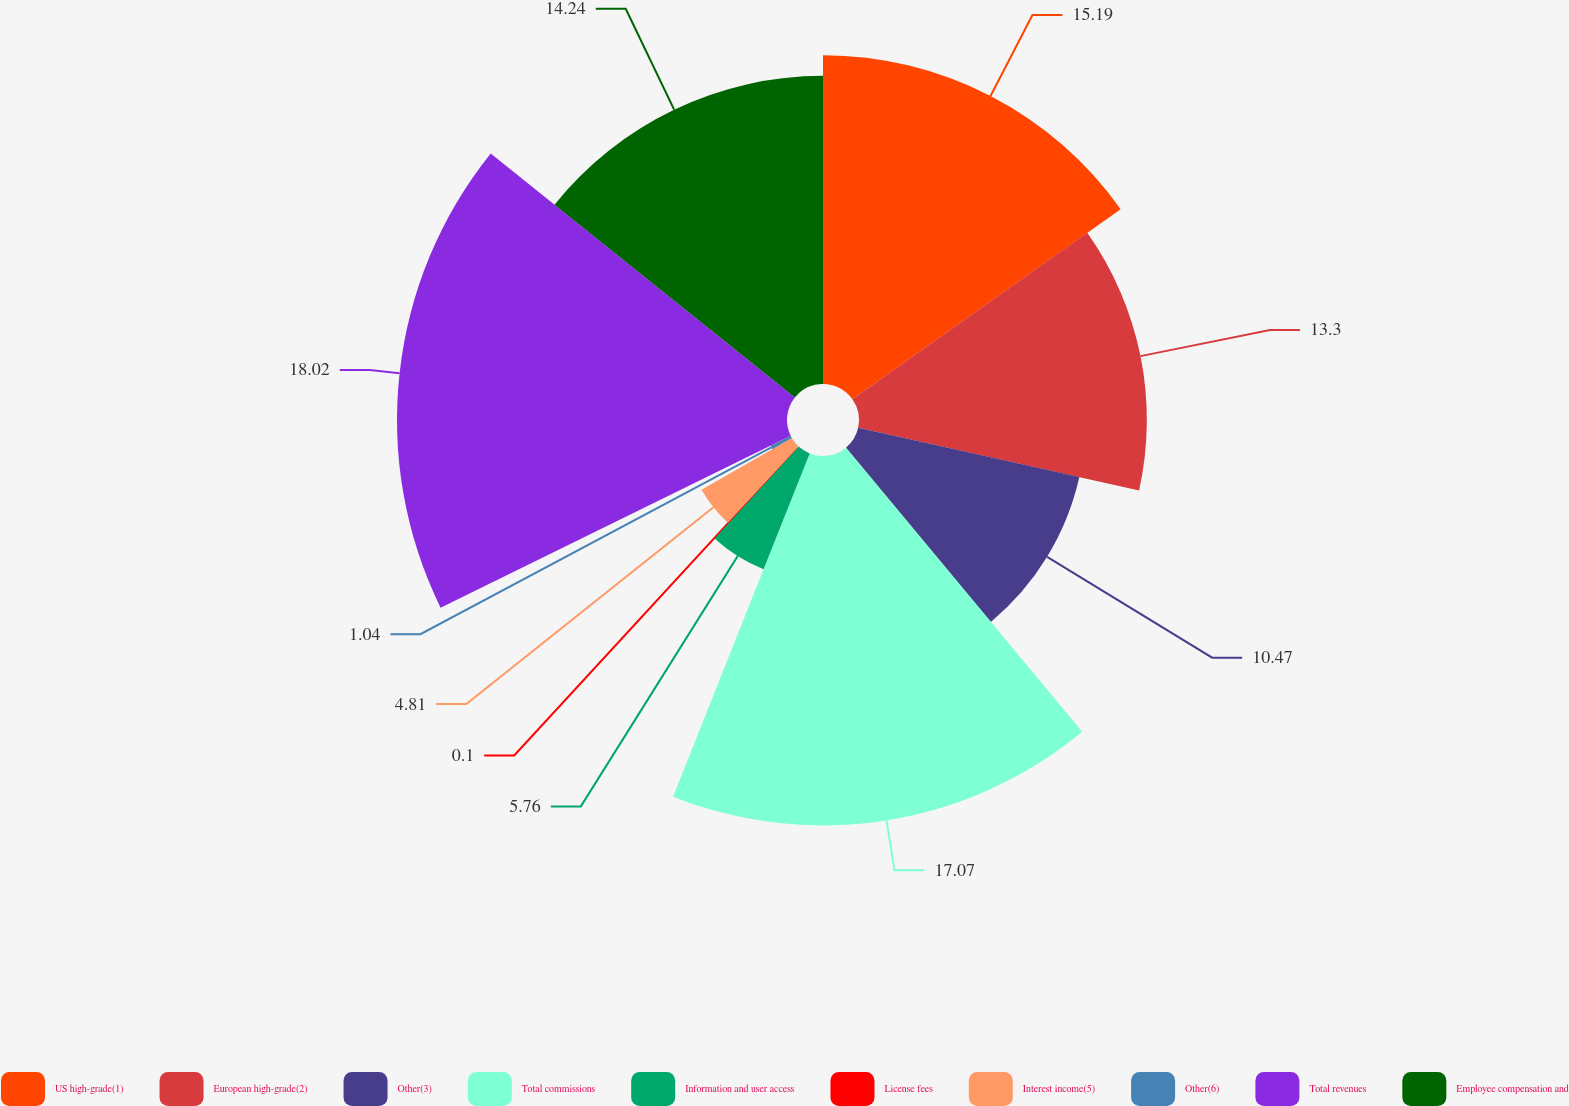Convert chart to OTSL. <chart><loc_0><loc_0><loc_500><loc_500><pie_chart><fcel>US high-grade(1)<fcel>European high-grade(2)<fcel>Other(3)<fcel>Total commissions<fcel>Information and user access<fcel>License fees<fcel>Interest income(5)<fcel>Other(6)<fcel>Total revenues<fcel>Employee compensation and<nl><fcel>15.19%<fcel>13.3%<fcel>10.47%<fcel>17.07%<fcel>5.76%<fcel>0.1%<fcel>4.81%<fcel>1.04%<fcel>18.02%<fcel>14.24%<nl></chart> 